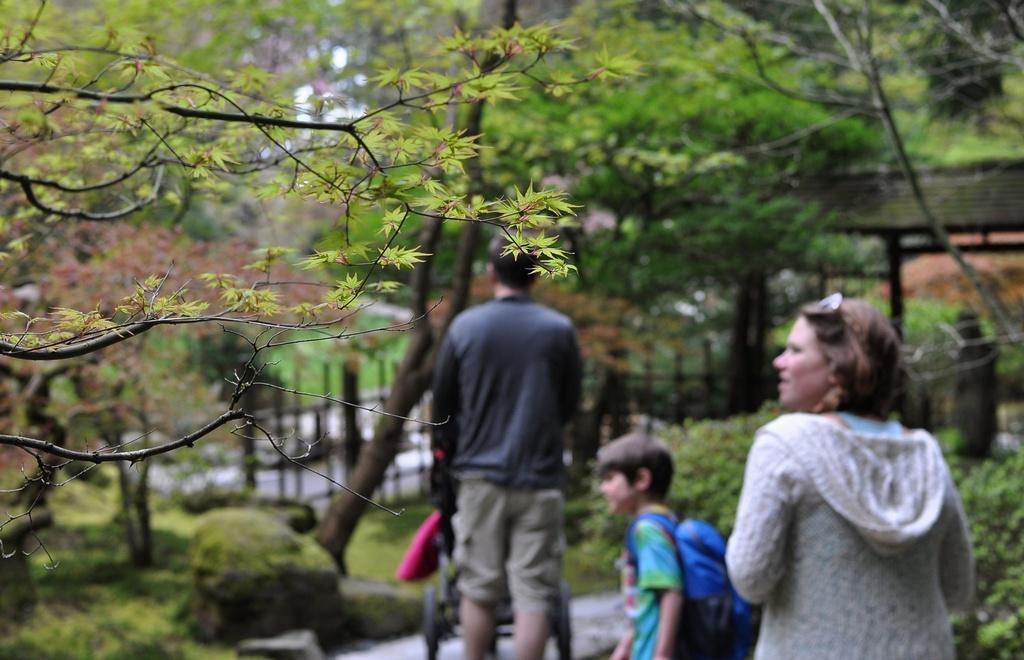In one or two sentences, can you explain what this image depicts? In the foreground of this image, on the left, there is a tree and we can also see a woman, a boy wearing backpack and a man holding a wheel cart on the path. On either side there is greenery. On the right, it seems like a shed and greenery in the background. 